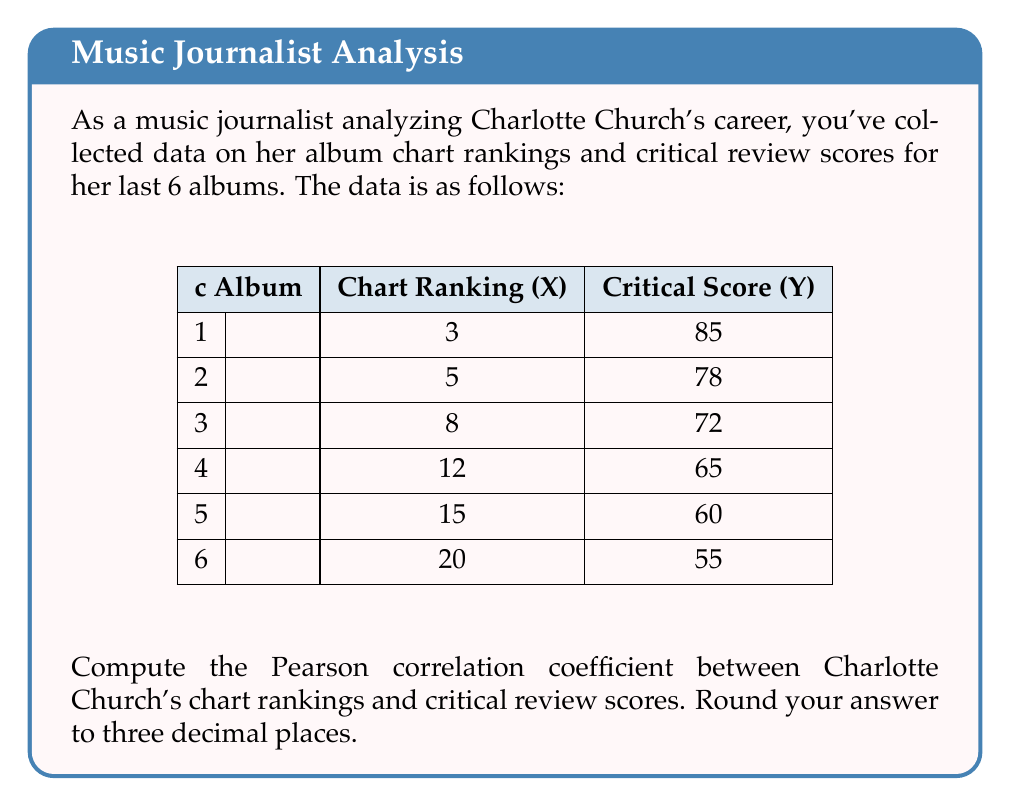Can you solve this math problem? To compute the Pearson correlation coefficient, we'll use the formula:

$$ r = \frac{\sum_{i=1}^{n} (x_i - \bar{x})(y_i - \bar{y})}{\sqrt{\sum_{i=1}^{n} (x_i - \bar{x})^2 \sum_{i=1}^{n} (y_i - \bar{y})^2}} $$

Where $x_i$ represents chart rankings and $y_i$ represents critical scores.

Step 1: Calculate the means
$\bar{x} = \frac{3 + 5 + 8 + 12 + 15 + 20}{6} = 10.5$
$\bar{y} = \frac{85 + 78 + 72 + 65 + 60 + 55}{6} = 69.1667$

Step 2: Calculate $(x_i - \bar{x})$, $(y_i - \bar{y})$, $(x_i - \bar{x})^2$, $(y_i - \bar{y})^2$, and $(x_i - \bar{x})(y_i - \bar{y})$

i | $x_i - \bar{x}$ | $y_i - \bar{y}$ | $(x_i - \bar{x})^2$ | $(y_i - \bar{y})^2$ | $(x_i - \bar{x})(y_i - \bar{y})$
1 | -7.5            | 15.8333         | 56.25               | 250.6944            | -118.75
2 | -5.5            | 8.8333          | 30.25               | 78.0278             | -48.5833
3 | -2.5            | 2.8333          | 6.25                | 8.0278              | -7.0833
4 | 1.5             | -4.1667         | 2.25                | 17.3611             | -6.25
5 | 4.5             | -9.1667         | 20.25               | 84.0278             | -41.25
6 | 9.5             | -14.1667        | 90.25               | 200.6944            | -134.5833

Step 3: Sum the columns
$\sum (x_i - \bar{x})^2 = 205.5$
$\sum (y_i - \bar{y})^2 = 638.8333$
$\sum (x_i - \bar{x})(y_i - \bar{y}) = -356.5$

Step 4: Apply the formula
$$ r = \frac{-356.5}{\sqrt{205.5 \times 638.8333}} = -0.9807 $$

Step 5: Round to three decimal places
$r \approx -0.981$
Answer: $-0.981$ 